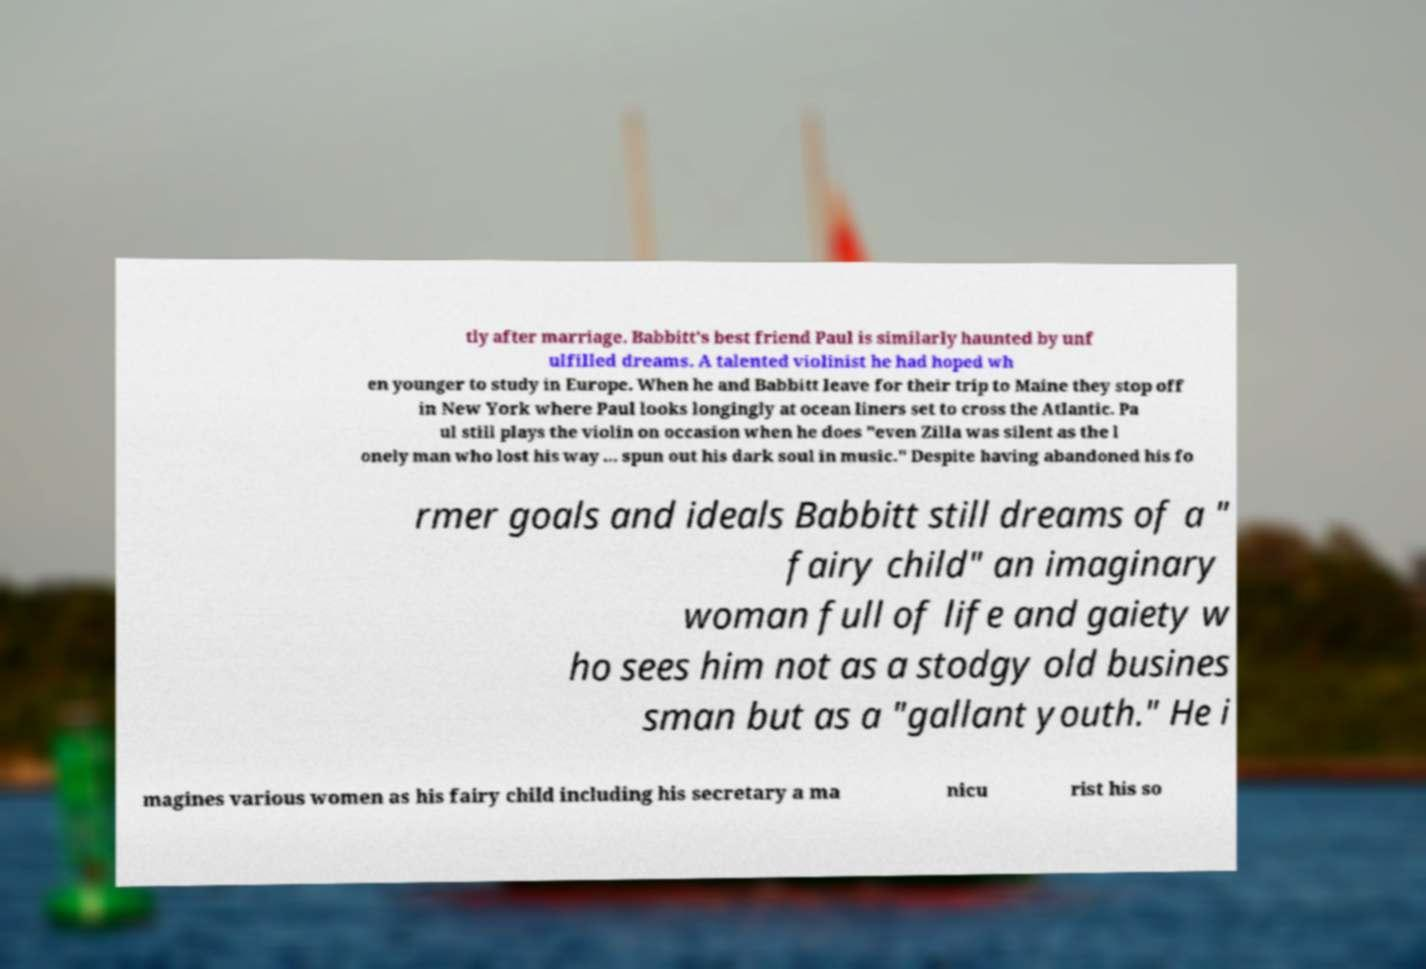Can you read and provide the text displayed in the image?This photo seems to have some interesting text. Can you extract and type it out for me? tly after marriage. Babbitt's best friend Paul is similarly haunted by unf ulfilled dreams. A talented violinist he had hoped wh en younger to study in Europe. When he and Babbitt leave for their trip to Maine they stop off in New York where Paul looks longingly at ocean liners set to cross the Atlantic. Pa ul still plays the violin on occasion when he does "even Zilla was silent as the l onely man who lost his way ... spun out his dark soul in music." Despite having abandoned his fo rmer goals and ideals Babbitt still dreams of a " fairy child" an imaginary woman full of life and gaiety w ho sees him not as a stodgy old busines sman but as a "gallant youth." He i magines various women as his fairy child including his secretary a ma nicu rist his so 